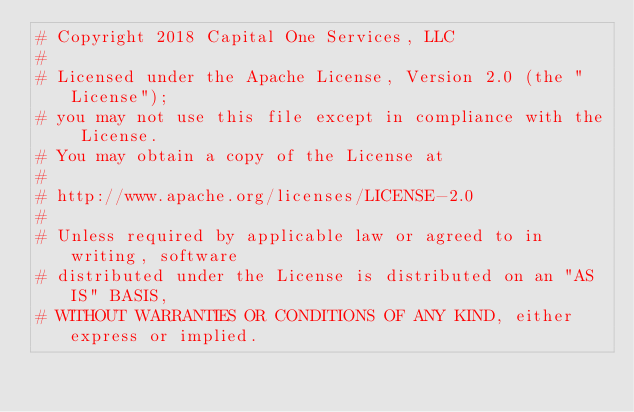<code> <loc_0><loc_0><loc_500><loc_500><_Python_># Copyright 2018 Capital One Services, LLC
#
# Licensed under the Apache License, Version 2.0 (the "License");
# you may not use this file except in compliance with the License.
# You may obtain a copy of the License at
#
# http://www.apache.org/licenses/LICENSE-2.0
#
# Unless required by applicable law or agreed to in writing, software
# distributed under the License is distributed on an "AS IS" BASIS,
# WITHOUT WARRANTIES OR CONDITIONS OF ANY KIND, either express or implied.</code> 